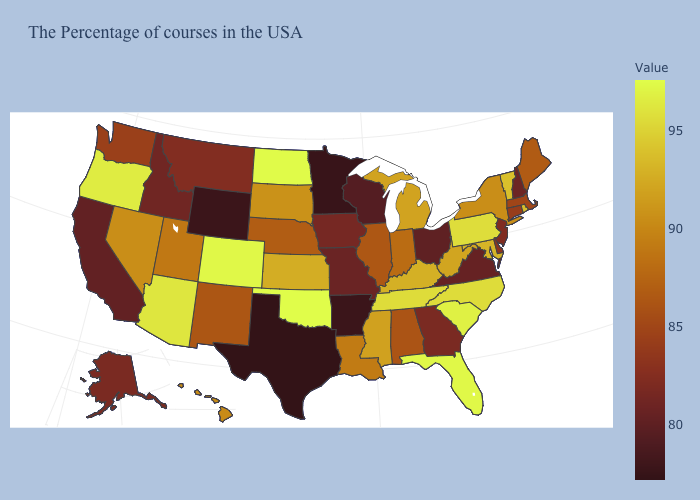Among the states that border Idaho , which have the highest value?
Be succinct. Oregon. Does Utah have the lowest value in the West?
Short answer required. No. Among the states that border Illinois , does Iowa have the highest value?
Answer briefly. No. Does Maine have the lowest value in the Northeast?
Short answer required. No. Which states hav the highest value in the West?
Concise answer only. Colorado. Does the map have missing data?
Give a very brief answer. No. Does North Dakota have the highest value in the MidWest?
Short answer required. Yes. Does Massachusetts have a lower value than Utah?
Concise answer only. Yes. Does the map have missing data?
Give a very brief answer. No. Among the states that border Vermont , does New Hampshire have the lowest value?
Concise answer only. Yes. Which states have the lowest value in the USA?
Keep it brief. Texas. 